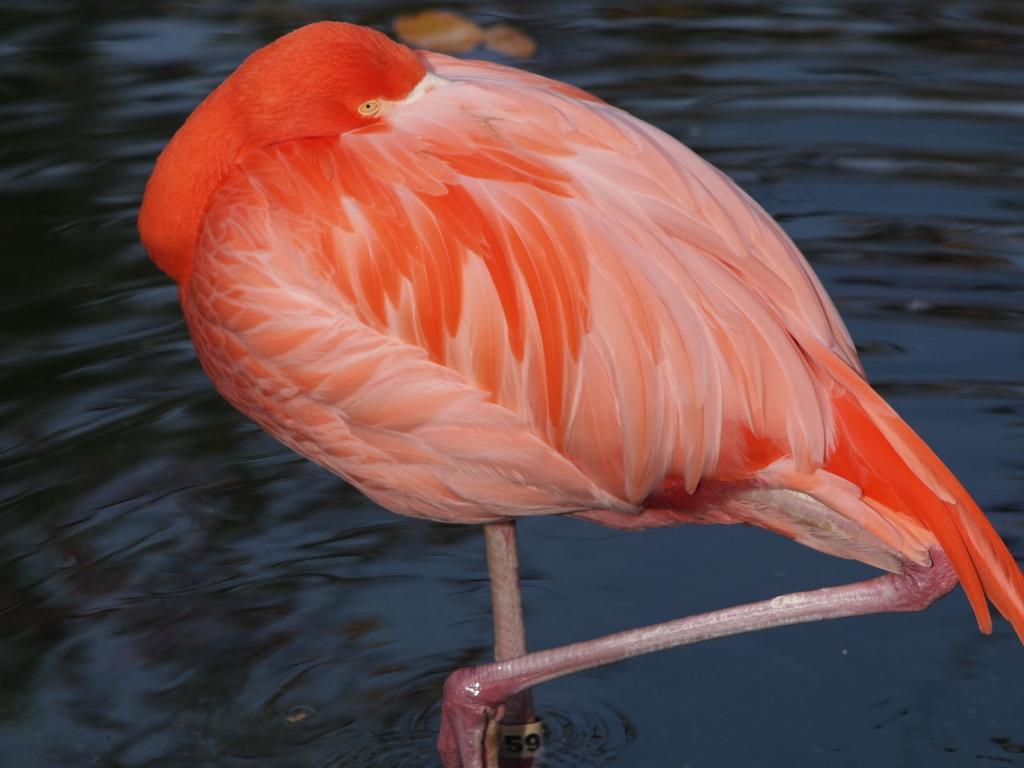How would you summarize this image in a sentence or two? In this image we can see a bird. In the background of the image there is water. 